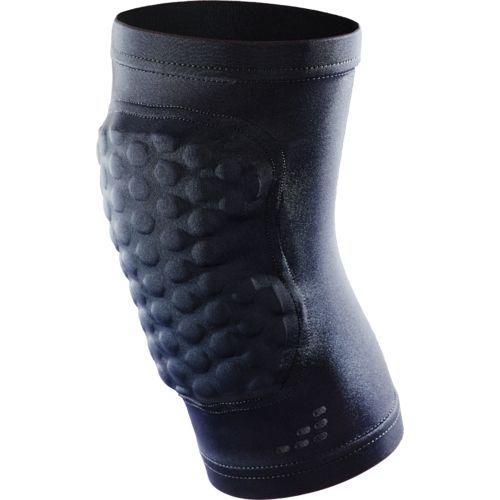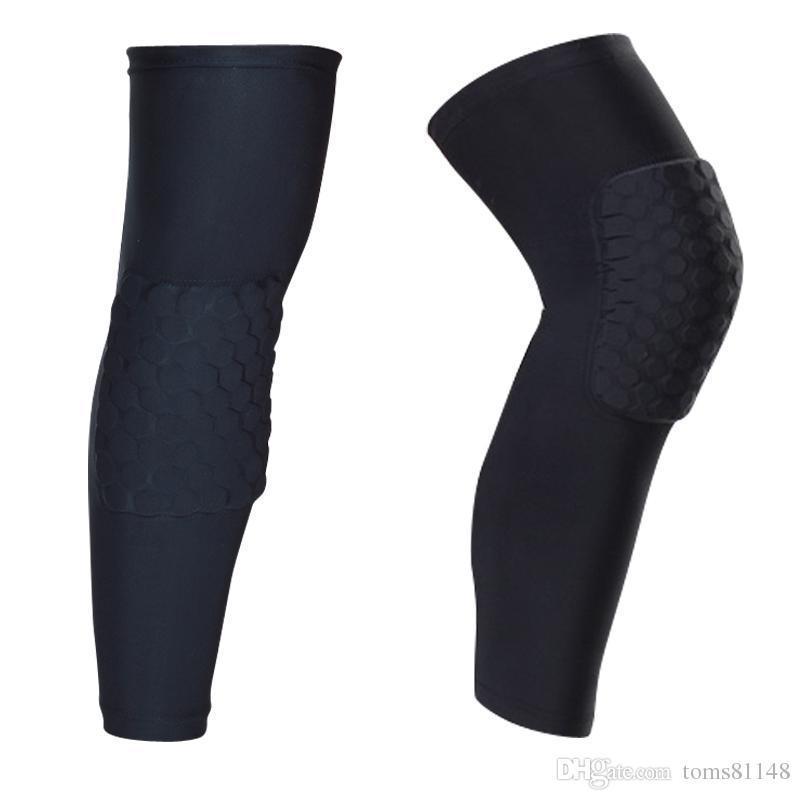The first image is the image on the left, the second image is the image on the right. For the images shown, is this caption "The left and right image contains a total of three knee pads." true? Answer yes or no. Yes. 